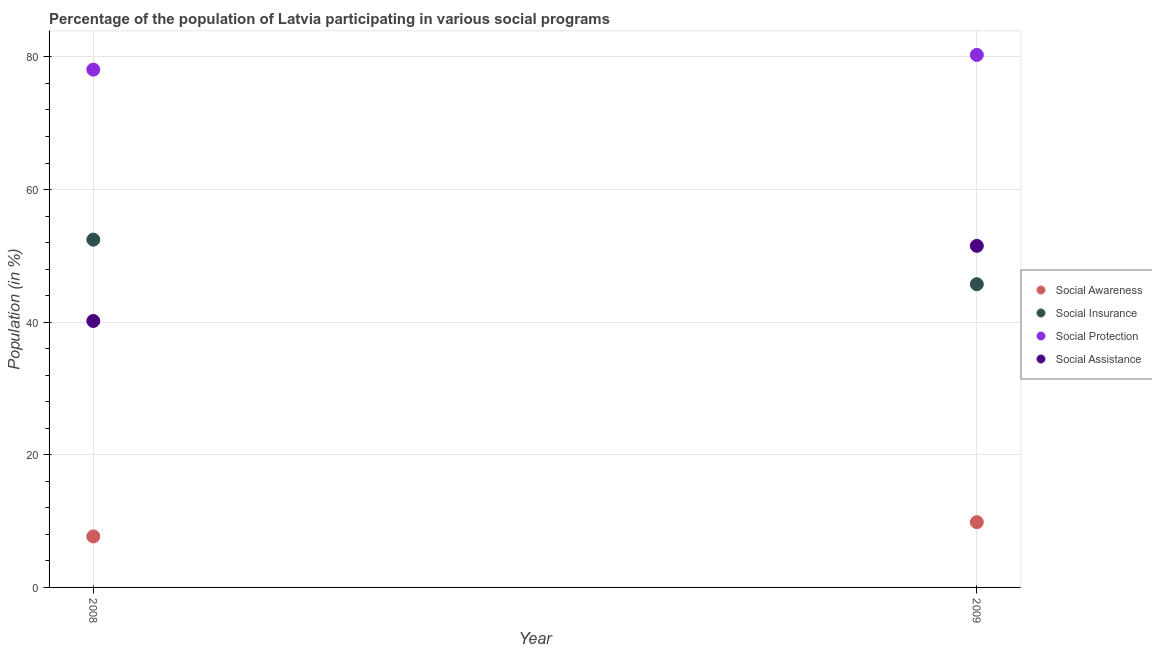What is the participation of population in social assistance programs in 2009?
Your answer should be compact. 51.51. Across all years, what is the maximum participation of population in social assistance programs?
Your answer should be very brief. 51.51. Across all years, what is the minimum participation of population in social insurance programs?
Make the answer very short. 45.72. In which year was the participation of population in social awareness programs maximum?
Provide a succinct answer. 2009. What is the total participation of population in social insurance programs in the graph?
Your response must be concise. 98.17. What is the difference between the participation of population in social assistance programs in 2008 and that in 2009?
Provide a short and direct response. -11.33. What is the difference between the participation of population in social insurance programs in 2008 and the participation of population in social protection programs in 2009?
Offer a terse response. -27.86. What is the average participation of population in social protection programs per year?
Keep it short and to the point. 79.19. In the year 2009, what is the difference between the participation of population in social assistance programs and participation of population in social insurance programs?
Offer a terse response. 5.78. In how many years, is the participation of population in social protection programs greater than 32 %?
Offer a very short reply. 2. What is the ratio of the participation of population in social protection programs in 2008 to that in 2009?
Keep it short and to the point. 0.97. In how many years, is the participation of population in social assistance programs greater than the average participation of population in social assistance programs taken over all years?
Give a very brief answer. 1. Does the participation of population in social assistance programs monotonically increase over the years?
Give a very brief answer. Yes. Is the participation of population in social awareness programs strictly less than the participation of population in social insurance programs over the years?
Ensure brevity in your answer.  Yes. How many years are there in the graph?
Ensure brevity in your answer.  2. What is the difference between two consecutive major ticks on the Y-axis?
Offer a very short reply. 20. Does the graph contain grids?
Offer a very short reply. Yes. What is the title of the graph?
Your answer should be compact. Percentage of the population of Latvia participating in various social programs . Does "Primary" appear as one of the legend labels in the graph?
Offer a terse response. No. What is the label or title of the X-axis?
Ensure brevity in your answer.  Year. What is the Population (in %) in Social Awareness in 2008?
Make the answer very short. 7.69. What is the Population (in %) of Social Insurance in 2008?
Ensure brevity in your answer.  52.44. What is the Population (in %) of Social Protection in 2008?
Provide a short and direct response. 78.08. What is the Population (in %) in Social Assistance in 2008?
Give a very brief answer. 40.18. What is the Population (in %) in Social Awareness in 2009?
Keep it short and to the point. 9.84. What is the Population (in %) in Social Insurance in 2009?
Your answer should be compact. 45.72. What is the Population (in %) of Social Protection in 2009?
Provide a succinct answer. 80.3. What is the Population (in %) of Social Assistance in 2009?
Give a very brief answer. 51.51. Across all years, what is the maximum Population (in %) in Social Awareness?
Offer a terse response. 9.84. Across all years, what is the maximum Population (in %) in Social Insurance?
Give a very brief answer. 52.44. Across all years, what is the maximum Population (in %) in Social Protection?
Your answer should be compact. 80.3. Across all years, what is the maximum Population (in %) in Social Assistance?
Give a very brief answer. 51.51. Across all years, what is the minimum Population (in %) of Social Awareness?
Keep it short and to the point. 7.69. Across all years, what is the minimum Population (in %) of Social Insurance?
Provide a short and direct response. 45.72. Across all years, what is the minimum Population (in %) of Social Protection?
Give a very brief answer. 78.08. Across all years, what is the minimum Population (in %) of Social Assistance?
Your answer should be very brief. 40.18. What is the total Population (in %) of Social Awareness in the graph?
Your response must be concise. 17.53. What is the total Population (in %) in Social Insurance in the graph?
Ensure brevity in your answer.  98.17. What is the total Population (in %) in Social Protection in the graph?
Your answer should be compact. 158.38. What is the total Population (in %) in Social Assistance in the graph?
Provide a short and direct response. 91.69. What is the difference between the Population (in %) of Social Awareness in 2008 and that in 2009?
Give a very brief answer. -2.15. What is the difference between the Population (in %) of Social Insurance in 2008 and that in 2009?
Your response must be concise. 6.72. What is the difference between the Population (in %) in Social Protection in 2008 and that in 2009?
Your response must be concise. -2.22. What is the difference between the Population (in %) of Social Assistance in 2008 and that in 2009?
Provide a succinct answer. -11.33. What is the difference between the Population (in %) of Social Awareness in 2008 and the Population (in %) of Social Insurance in 2009?
Your response must be concise. -38.03. What is the difference between the Population (in %) in Social Awareness in 2008 and the Population (in %) in Social Protection in 2009?
Give a very brief answer. -72.61. What is the difference between the Population (in %) in Social Awareness in 2008 and the Population (in %) in Social Assistance in 2009?
Keep it short and to the point. -43.81. What is the difference between the Population (in %) in Social Insurance in 2008 and the Population (in %) in Social Protection in 2009?
Offer a terse response. -27.86. What is the difference between the Population (in %) in Social Insurance in 2008 and the Population (in %) in Social Assistance in 2009?
Offer a terse response. 0.94. What is the difference between the Population (in %) in Social Protection in 2008 and the Population (in %) in Social Assistance in 2009?
Your response must be concise. 26.57. What is the average Population (in %) in Social Awareness per year?
Your answer should be very brief. 8.77. What is the average Population (in %) of Social Insurance per year?
Make the answer very short. 49.08. What is the average Population (in %) in Social Protection per year?
Your answer should be compact. 79.19. What is the average Population (in %) in Social Assistance per year?
Your answer should be very brief. 45.84. In the year 2008, what is the difference between the Population (in %) of Social Awareness and Population (in %) of Social Insurance?
Make the answer very short. -44.75. In the year 2008, what is the difference between the Population (in %) in Social Awareness and Population (in %) in Social Protection?
Your answer should be very brief. -70.39. In the year 2008, what is the difference between the Population (in %) of Social Awareness and Population (in %) of Social Assistance?
Ensure brevity in your answer.  -32.49. In the year 2008, what is the difference between the Population (in %) in Social Insurance and Population (in %) in Social Protection?
Your response must be concise. -25.64. In the year 2008, what is the difference between the Population (in %) of Social Insurance and Population (in %) of Social Assistance?
Make the answer very short. 12.26. In the year 2008, what is the difference between the Population (in %) of Social Protection and Population (in %) of Social Assistance?
Provide a short and direct response. 37.9. In the year 2009, what is the difference between the Population (in %) of Social Awareness and Population (in %) of Social Insurance?
Your answer should be compact. -35.88. In the year 2009, what is the difference between the Population (in %) of Social Awareness and Population (in %) of Social Protection?
Provide a short and direct response. -70.46. In the year 2009, what is the difference between the Population (in %) in Social Awareness and Population (in %) in Social Assistance?
Offer a very short reply. -41.67. In the year 2009, what is the difference between the Population (in %) in Social Insurance and Population (in %) in Social Protection?
Offer a very short reply. -34.58. In the year 2009, what is the difference between the Population (in %) in Social Insurance and Population (in %) in Social Assistance?
Your response must be concise. -5.78. In the year 2009, what is the difference between the Population (in %) in Social Protection and Population (in %) in Social Assistance?
Your response must be concise. 28.8. What is the ratio of the Population (in %) of Social Awareness in 2008 to that in 2009?
Provide a short and direct response. 0.78. What is the ratio of the Population (in %) in Social Insurance in 2008 to that in 2009?
Your answer should be compact. 1.15. What is the ratio of the Population (in %) of Social Protection in 2008 to that in 2009?
Provide a succinct answer. 0.97. What is the ratio of the Population (in %) of Social Assistance in 2008 to that in 2009?
Offer a terse response. 0.78. What is the difference between the highest and the second highest Population (in %) in Social Awareness?
Keep it short and to the point. 2.15. What is the difference between the highest and the second highest Population (in %) in Social Insurance?
Make the answer very short. 6.72. What is the difference between the highest and the second highest Population (in %) in Social Protection?
Make the answer very short. 2.22. What is the difference between the highest and the second highest Population (in %) of Social Assistance?
Ensure brevity in your answer.  11.33. What is the difference between the highest and the lowest Population (in %) of Social Awareness?
Ensure brevity in your answer.  2.15. What is the difference between the highest and the lowest Population (in %) of Social Insurance?
Give a very brief answer. 6.72. What is the difference between the highest and the lowest Population (in %) in Social Protection?
Your response must be concise. 2.22. What is the difference between the highest and the lowest Population (in %) of Social Assistance?
Provide a succinct answer. 11.33. 